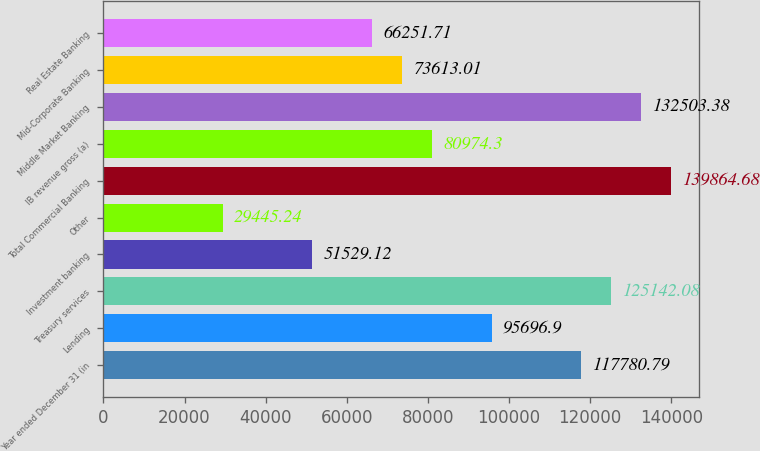Convert chart. <chart><loc_0><loc_0><loc_500><loc_500><bar_chart><fcel>Year ended December 31 (in<fcel>Lending<fcel>Treasury services<fcel>Investment banking<fcel>Other<fcel>Total Commercial Banking<fcel>IB revenue gross (a)<fcel>Middle Market Banking<fcel>Mid-Corporate Banking<fcel>Real Estate Banking<nl><fcel>117781<fcel>95696.9<fcel>125142<fcel>51529.1<fcel>29445.2<fcel>139865<fcel>80974.3<fcel>132503<fcel>73613<fcel>66251.7<nl></chart> 